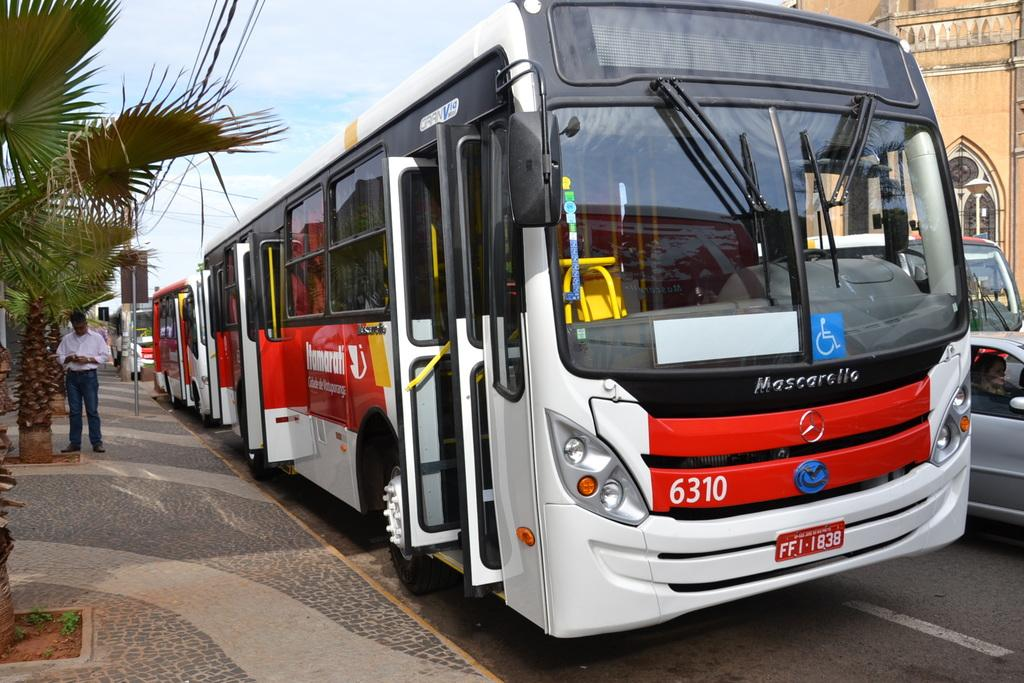What type of structure is present in the image? There is a building in the image. What vehicles can be seen in the image? There are cars and buses in the image. What is visible in the sky in the image? The sky is visible in the image. What type of vegetation is present in the image? There are trees in the image. Can you describe the person in the image? There is a person standing on the left side of the image. How does the jelly affect the building in the image? There is no jelly present in the image, so it cannot affect the building. 